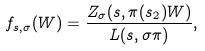Convert formula to latex. <formula><loc_0><loc_0><loc_500><loc_500>f _ { s , \sigma } ( W ) = \frac { Z _ { \sigma } ( s , \pi ( s _ { 2 } ) W ) } { L ( s , \sigma \pi ) } ,</formula> 